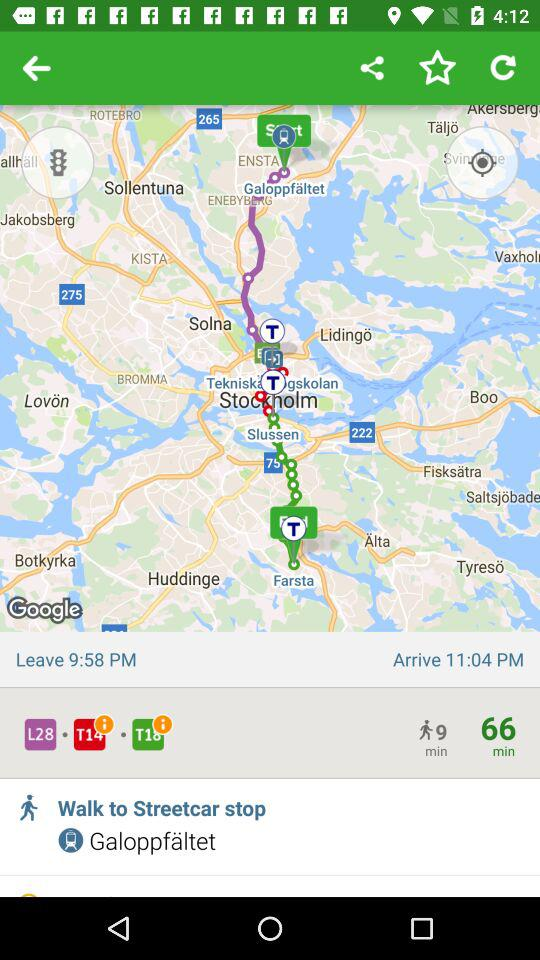What is the arrival time? The arrival time is 11:04 PM. 